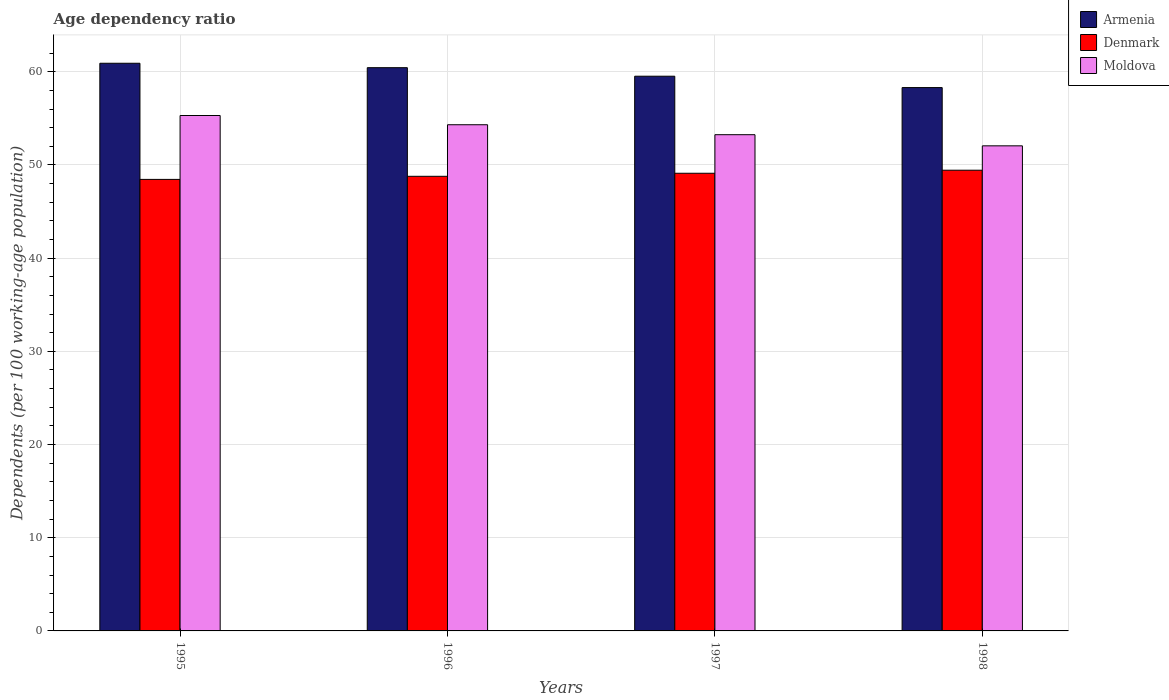How many different coloured bars are there?
Your answer should be compact. 3. How many bars are there on the 3rd tick from the left?
Offer a terse response. 3. In how many cases, is the number of bars for a given year not equal to the number of legend labels?
Provide a short and direct response. 0. What is the age dependency ratio in in Armenia in 1995?
Give a very brief answer. 60.91. Across all years, what is the maximum age dependency ratio in in Armenia?
Your answer should be very brief. 60.91. Across all years, what is the minimum age dependency ratio in in Armenia?
Provide a short and direct response. 58.3. In which year was the age dependency ratio in in Armenia maximum?
Provide a short and direct response. 1995. In which year was the age dependency ratio in in Armenia minimum?
Your answer should be compact. 1998. What is the total age dependency ratio in in Denmark in the graph?
Your response must be concise. 195.78. What is the difference between the age dependency ratio in in Armenia in 1995 and that in 1996?
Provide a succinct answer. 0.47. What is the difference between the age dependency ratio in in Moldova in 1997 and the age dependency ratio in in Armenia in 1995?
Provide a succinct answer. -7.67. What is the average age dependency ratio in in Armenia per year?
Offer a very short reply. 59.8. In the year 1997, what is the difference between the age dependency ratio in in Moldova and age dependency ratio in in Armenia?
Give a very brief answer. -6.28. In how many years, is the age dependency ratio in in Armenia greater than 50 %?
Keep it short and to the point. 4. What is the ratio of the age dependency ratio in in Denmark in 1995 to that in 1997?
Your response must be concise. 0.99. What is the difference between the highest and the second highest age dependency ratio in in Denmark?
Your response must be concise. 0.33. What is the difference between the highest and the lowest age dependency ratio in in Denmark?
Your answer should be compact. 0.99. What does the 1st bar from the left in 1998 represents?
Give a very brief answer. Armenia. What does the 3rd bar from the right in 1998 represents?
Offer a very short reply. Armenia. How many bars are there?
Make the answer very short. 12. Are the values on the major ticks of Y-axis written in scientific E-notation?
Give a very brief answer. No. Does the graph contain grids?
Offer a very short reply. Yes. Where does the legend appear in the graph?
Provide a succinct answer. Top right. How are the legend labels stacked?
Ensure brevity in your answer.  Vertical. What is the title of the graph?
Your response must be concise. Age dependency ratio. What is the label or title of the Y-axis?
Make the answer very short. Dependents (per 100 working-age population). What is the Dependents (per 100 working-age population) in Armenia in 1995?
Give a very brief answer. 60.91. What is the Dependents (per 100 working-age population) in Denmark in 1995?
Keep it short and to the point. 48.45. What is the Dependents (per 100 working-age population) of Moldova in 1995?
Your response must be concise. 55.31. What is the Dependents (per 100 working-age population) in Armenia in 1996?
Keep it short and to the point. 60.44. What is the Dependents (per 100 working-age population) in Denmark in 1996?
Keep it short and to the point. 48.78. What is the Dependents (per 100 working-age population) in Moldova in 1996?
Keep it short and to the point. 54.32. What is the Dependents (per 100 working-age population) of Armenia in 1997?
Give a very brief answer. 59.52. What is the Dependents (per 100 working-age population) in Denmark in 1997?
Give a very brief answer. 49.11. What is the Dependents (per 100 working-age population) in Moldova in 1997?
Your response must be concise. 53.25. What is the Dependents (per 100 working-age population) in Armenia in 1998?
Give a very brief answer. 58.3. What is the Dependents (per 100 working-age population) in Denmark in 1998?
Ensure brevity in your answer.  49.44. What is the Dependents (per 100 working-age population) of Moldova in 1998?
Your response must be concise. 52.05. Across all years, what is the maximum Dependents (per 100 working-age population) in Armenia?
Your answer should be very brief. 60.91. Across all years, what is the maximum Dependents (per 100 working-age population) of Denmark?
Offer a terse response. 49.44. Across all years, what is the maximum Dependents (per 100 working-age population) of Moldova?
Ensure brevity in your answer.  55.31. Across all years, what is the minimum Dependents (per 100 working-age population) in Armenia?
Provide a short and direct response. 58.3. Across all years, what is the minimum Dependents (per 100 working-age population) in Denmark?
Your response must be concise. 48.45. Across all years, what is the minimum Dependents (per 100 working-age population) in Moldova?
Offer a very short reply. 52.05. What is the total Dependents (per 100 working-age population) in Armenia in the graph?
Keep it short and to the point. 239.18. What is the total Dependents (per 100 working-age population) of Denmark in the graph?
Keep it short and to the point. 195.78. What is the total Dependents (per 100 working-age population) of Moldova in the graph?
Ensure brevity in your answer.  214.93. What is the difference between the Dependents (per 100 working-age population) in Armenia in 1995 and that in 1996?
Provide a succinct answer. 0.47. What is the difference between the Dependents (per 100 working-age population) in Denmark in 1995 and that in 1996?
Give a very brief answer. -0.33. What is the difference between the Dependents (per 100 working-age population) of Armenia in 1995 and that in 1997?
Provide a short and direct response. 1.39. What is the difference between the Dependents (per 100 working-age population) of Denmark in 1995 and that in 1997?
Provide a succinct answer. -0.66. What is the difference between the Dependents (per 100 working-age population) in Moldova in 1995 and that in 1997?
Offer a very short reply. 2.06. What is the difference between the Dependents (per 100 working-age population) in Armenia in 1995 and that in 1998?
Ensure brevity in your answer.  2.61. What is the difference between the Dependents (per 100 working-age population) of Denmark in 1995 and that in 1998?
Provide a short and direct response. -0.99. What is the difference between the Dependents (per 100 working-age population) of Moldova in 1995 and that in 1998?
Ensure brevity in your answer.  3.25. What is the difference between the Dependents (per 100 working-age population) of Armenia in 1996 and that in 1997?
Make the answer very short. 0.92. What is the difference between the Dependents (per 100 working-age population) of Denmark in 1996 and that in 1997?
Provide a succinct answer. -0.33. What is the difference between the Dependents (per 100 working-age population) in Moldova in 1996 and that in 1997?
Make the answer very short. 1.07. What is the difference between the Dependents (per 100 working-age population) of Armenia in 1996 and that in 1998?
Give a very brief answer. 2.14. What is the difference between the Dependents (per 100 working-age population) of Denmark in 1996 and that in 1998?
Provide a succinct answer. -0.65. What is the difference between the Dependents (per 100 working-age population) in Moldova in 1996 and that in 1998?
Make the answer very short. 2.26. What is the difference between the Dependents (per 100 working-age population) in Armenia in 1997 and that in 1998?
Give a very brief answer. 1.22. What is the difference between the Dependents (per 100 working-age population) in Denmark in 1997 and that in 1998?
Provide a short and direct response. -0.33. What is the difference between the Dependents (per 100 working-age population) of Moldova in 1997 and that in 1998?
Provide a short and direct response. 1.2. What is the difference between the Dependents (per 100 working-age population) of Armenia in 1995 and the Dependents (per 100 working-age population) of Denmark in 1996?
Provide a short and direct response. 12.13. What is the difference between the Dependents (per 100 working-age population) in Armenia in 1995 and the Dependents (per 100 working-age population) in Moldova in 1996?
Your answer should be very brief. 6.6. What is the difference between the Dependents (per 100 working-age population) in Denmark in 1995 and the Dependents (per 100 working-age population) in Moldova in 1996?
Your response must be concise. -5.86. What is the difference between the Dependents (per 100 working-age population) in Armenia in 1995 and the Dependents (per 100 working-age population) in Denmark in 1997?
Make the answer very short. 11.8. What is the difference between the Dependents (per 100 working-age population) in Armenia in 1995 and the Dependents (per 100 working-age population) in Moldova in 1997?
Offer a terse response. 7.67. What is the difference between the Dependents (per 100 working-age population) in Denmark in 1995 and the Dependents (per 100 working-age population) in Moldova in 1997?
Provide a succinct answer. -4.8. What is the difference between the Dependents (per 100 working-age population) of Armenia in 1995 and the Dependents (per 100 working-age population) of Denmark in 1998?
Provide a short and direct response. 11.48. What is the difference between the Dependents (per 100 working-age population) in Armenia in 1995 and the Dependents (per 100 working-age population) in Moldova in 1998?
Offer a terse response. 8.86. What is the difference between the Dependents (per 100 working-age population) of Denmark in 1995 and the Dependents (per 100 working-age population) of Moldova in 1998?
Give a very brief answer. -3.6. What is the difference between the Dependents (per 100 working-age population) of Armenia in 1996 and the Dependents (per 100 working-age population) of Denmark in 1997?
Provide a succinct answer. 11.33. What is the difference between the Dependents (per 100 working-age population) of Armenia in 1996 and the Dependents (per 100 working-age population) of Moldova in 1997?
Ensure brevity in your answer.  7.19. What is the difference between the Dependents (per 100 working-age population) of Denmark in 1996 and the Dependents (per 100 working-age population) of Moldova in 1997?
Provide a short and direct response. -4.47. What is the difference between the Dependents (per 100 working-age population) in Armenia in 1996 and the Dependents (per 100 working-age population) in Denmark in 1998?
Provide a succinct answer. 11. What is the difference between the Dependents (per 100 working-age population) in Armenia in 1996 and the Dependents (per 100 working-age population) in Moldova in 1998?
Ensure brevity in your answer.  8.39. What is the difference between the Dependents (per 100 working-age population) of Denmark in 1996 and the Dependents (per 100 working-age population) of Moldova in 1998?
Your answer should be compact. -3.27. What is the difference between the Dependents (per 100 working-age population) of Armenia in 1997 and the Dependents (per 100 working-age population) of Denmark in 1998?
Your answer should be very brief. 10.09. What is the difference between the Dependents (per 100 working-age population) in Armenia in 1997 and the Dependents (per 100 working-age population) in Moldova in 1998?
Provide a short and direct response. 7.47. What is the difference between the Dependents (per 100 working-age population) of Denmark in 1997 and the Dependents (per 100 working-age population) of Moldova in 1998?
Make the answer very short. -2.94. What is the average Dependents (per 100 working-age population) of Armenia per year?
Offer a terse response. 59.8. What is the average Dependents (per 100 working-age population) in Denmark per year?
Your answer should be compact. 48.95. What is the average Dependents (per 100 working-age population) of Moldova per year?
Keep it short and to the point. 53.73. In the year 1995, what is the difference between the Dependents (per 100 working-age population) in Armenia and Dependents (per 100 working-age population) in Denmark?
Provide a short and direct response. 12.46. In the year 1995, what is the difference between the Dependents (per 100 working-age population) in Armenia and Dependents (per 100 working-age population) in Moldova?
Provide a short and direct response. 5.61. In the year 1995, what is the difference between the Dependents (per 100 working-age population) of Denmark and Dependents (per 100 working-age population) of Moldova?
Your answer should be compact. -6.86. In the year 1996, what is the difference between the Dependents (per 100 working-age population) of Armenia and Dependents (per 100 working-age population) of Denmark?
Your answer should be very brief. 11.66. In the year 1996, what is the difference between the Dependents (per 100 working-age population) in Armenia and Dependents (per 100 working-age population) in Moldova?
Ensure brevity in your answer.  6.12. In the year 1996, what is the difference between the Dependents (per 100 working-age population) in Denmark and Dependents (per 100 working-age population) in Moldova?
Make the answer very short. -5.53. In the year 1997, what is the difference between the Dependents (per 100 working-age population) in Armenia and Dependents (per 100 working-age population) in Denmark?
Give a very brief answer. 10.41. In the year 1997, what is the difference between the Dependents (per 100 working-age population) in Armenia and Dependents (per 100 working-age population) in Moldova?
Your answer should be very brief. 6.28. In the year 1997, what is the difference between the Dependents (per 100 working-age population) in Denmark and Dependents (per 100 working-age population) in Moldova?
Your answer should be very brief. -4.14. In the year 1998, what is the difference between the Dependents (per 100 working-age population) in Armenia and Dependents (per 100 working-age population) in Denmark?
Give a very brief answer. 8.87. In the year 1998, what is the difference between the Dependents (per 100 working-age population) in Armenia and Dependents (per 100 working-age population) in Moldova?
Provide a short and direct response. 6.25. In the year 1998, what is the difference between the Dependents (per 100 working-age population) in Denmark and Dependents (per 100 working-age population) in Moldova?
Ensure brevity in your answer.  -2.62. What is the ratio of the Dependents (per 100 working-age population) in Armenia in 1995 to that in 1996?
Offer a very short reply. 1.01. What is the ratio of the Dependents (per 100 working-age population) in Denmark in 1995 to that in 1996?
Provide a short and direct response. 0.99. What is the ratio of the Dependents (per 100 working-age population) in Moldova in 1995 to that in 1996?
Give a very brief answer. 1.02. What is the ratio of the Dependents (per 100 working-age population) in Armenia in 1995 to that in 1997?
Offer a very short reply. 1.02. What is the ratio of the Dependents (per 100 working-age population) of Denmark in 1995 to that in 1997?
Ensure brevity in your answer.  0.99. What is the ratio of the Dependents (per 100 working-age population) in Moldova in 1995 to that in 1997?
Ensure brevity in your answer.  1.04. What is the ratio of the Dependents (per 100 working-age population) of Armenia in 1995 to that in 1998?
Your response must be concise. 1.04. What is the ratio of the Dependents (per 100 working-age population) of Denmark in 1995 to that in 1998?
Make the answer very short. 0.98. What is the ratio of the Dependents (per 100 working-age population) of Armenia in 1996 to that in 1997?
Make the answer very short. 1.02. What is the ratio of the Dependents (per 100 working-age population) in Denmark in 1996 to that in 1997?
Your answer should be very brief. 0.99. What is the ratio of the Dependents (per 100 working-age population) in Moldova in 1996 to that in 1997?
Offer a very short reply. 1.02. What is the ratio of the Dependents (per 100 working-age population) of Armenia in 1996 to that in 1998?
Your answer should be very brief. 1.04. What is the ratio of the Dependents (per 100 working-age population) in Moldova in 1996 to that in 1998?
Your answer should be very brief. 1.04. What is the ratio of the Dependents (per 100 working-age population) of Armenia in 1997 to that in 1998?
Your answer should be very brief. 1.02. What is the difference between the highest and the second highest Dependents (per 100 working-age population) in Armenia?
Ensure brevity in your answer.  0.47. What is the difference between the highest and the second highest Dependents (per 100 working-age population) in Denmark?
Provide a succinct answer. 0.33. What is the difference between the highest and the lowest Dependents (per 100 working-age population) of Armenia?
Give a very brief answer. 2.61. What is the difference between the highest and the lowest Dependents (per 100 working-age population) in Denmark?
Your answer should be very brief. 0.99. What is the difference between the highest and the lowest Dependents (per 100 working-age population) of Moldova?
Offer a terse response. 3.25. 